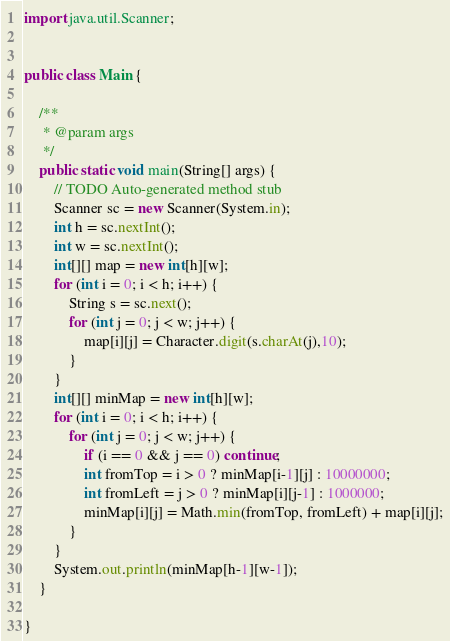Convert code to text. <code><loc_0><loc_0><loc_500><loc_500><_Java_>import java.util.Scanner;


public class Main {

    /**
     * @param args
     */
    public static void main(String[] args) {
        // TODO Auto-generated method stub
        Scanner sc = new Scanner(System.in);
        int h = sc.nextInt();
        int w = sc.nextInt();
        int[][] map = new int[h][w];
        for (int i = 0; i < h; i++) {
            String s = sc.next();
            for (int j = 0; j < w; j++) {
                map[i][j] = Character.digit(s.charAt(j),10);
            }
        }
        int[][] minMap = new int[h][w];
        for (int i = 0; i < h; i++) {
            for (int j = 0; j < w; j++) {
                if (i == 0 && j == 0) continue;
                int fromTop = i > 0 ? minMap[i-1][j] : 10000000;
                int fromLeft = j > 0 ? minMap[i][j-1] : 1000000;
                minMap[i][j] = Math.min(fromTop, fromLeft) + map[i][j];
            }
        }
        System.out.println(minMap[h-1][w-1]);
    }

}</code> 